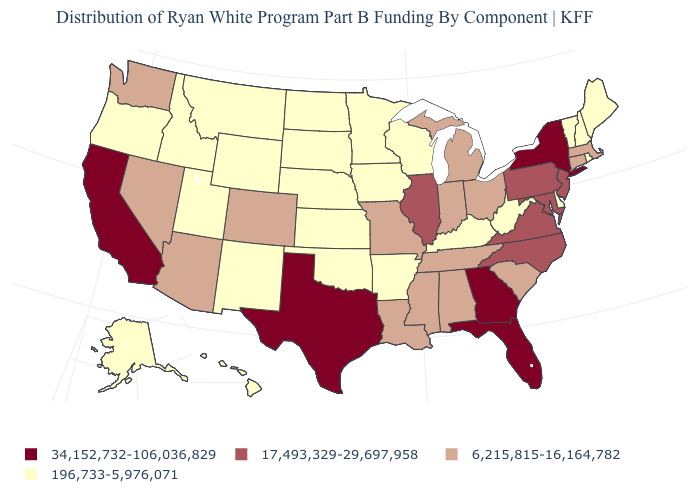Among the states that border Michigan , does Indiana have the highest value?
Keep it brief. Yes. What is the value of Wyoming?
Answer briefly. 196,733-5,976,071. Which states have the lowest value in the USA?
Concise answer only. Alaska, Arkansas, Delaware, Hawaii, Idaho, Iowa, Kansas, Kentucky, Maine, Minnesota, Montana, Nebraska, New Hampshire, New Mexico, North Dakota, Oklahoma, Oregon, Rhode Island, South Dakota, Utah, Vermont, West Virginia, Wisconsin, Wyoming. What is the lowest value in the USA?
Be succinct. 196,733-5,976,071. Is the legend a continuous bar?
Short answer required. No. Which states have the lowest value in the USA?
Be succinct. Alaska, Arkansas, Delaware, Hawaii, Idaho, Iowa, Kansas, Kentucky, Maine, Minnesota, Montana, Nebraska, New Hampshire, New Mexico, North Dakota, Oklahoma, Oregon, Rhode Island, South Dakota, Utah, Vermont, West Virginia, Wisconsin, Wyoming. What is the value of Louisiana?
Be succinct. 6,215,815-16,164,782. Name the states that have a value in the range 34,152,732-106,036,829?
Write a very short answer. California, Florida, Georgia, New York, Texas. What is the highest value in the MidWest ?
Give a very brief answer. 17,493,329-29,697,958. Which states have the lowest value in the USA?
Short answer required. Alaska, Arkansas, Delaware, Hawaii, Idaho, Iowa, Kansas, Kentucky, Maine, Minnesota, Montana, Nebraska, New Hampshire, New Mexico, North Dakota, Oklahoma, Oregon, Rhode Island, South Dakota, Utah, Vermont, West Virginia, Wisconsin, Wyoming. Among the states that border Ohio , which have the highest value?
Give a very brief answer. Pennsylvania. What is the value of Texas?
Give a very brief answer. 34,152,732-106,036,829. What is the value of New Hampshire?
Quick response, please. 196,733-5,976,071. What is the value of New Jersey?
Write a very short answer. 17,493,329-29,697,958. What is the value of Indiana?
Be succinct. 6,215,815-16,164,782. 